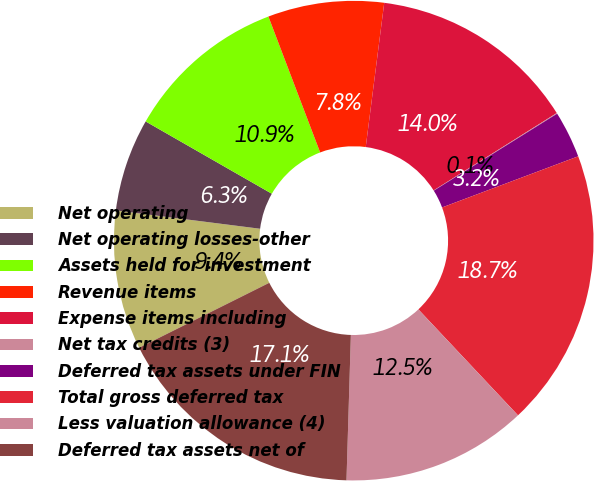<chart> <loc_0><loc_0><loc_500><loc_500><pie_chart><fcel>Net operating<fcel>Net operating losses-other<fcel>Assets held for investment<fcel>Revenue items<fcel>Expense items including<fcel>Net tax credits (3)<fcel>Deferred tax assets under FIN<fcel>Total gross deferred tax<fcel>Less valuation allowance (4)<fcel>Deferred tax assets net of<nl><fcel>9.38%<fcel>6.27%<fcel>10.93%<fcel>7.82%<fcel>14.04%<fcel>0.05%<fcel>3.16%<fcel>18.71%<fcel>12.49%<fcel>17.15%<nl></chart> 